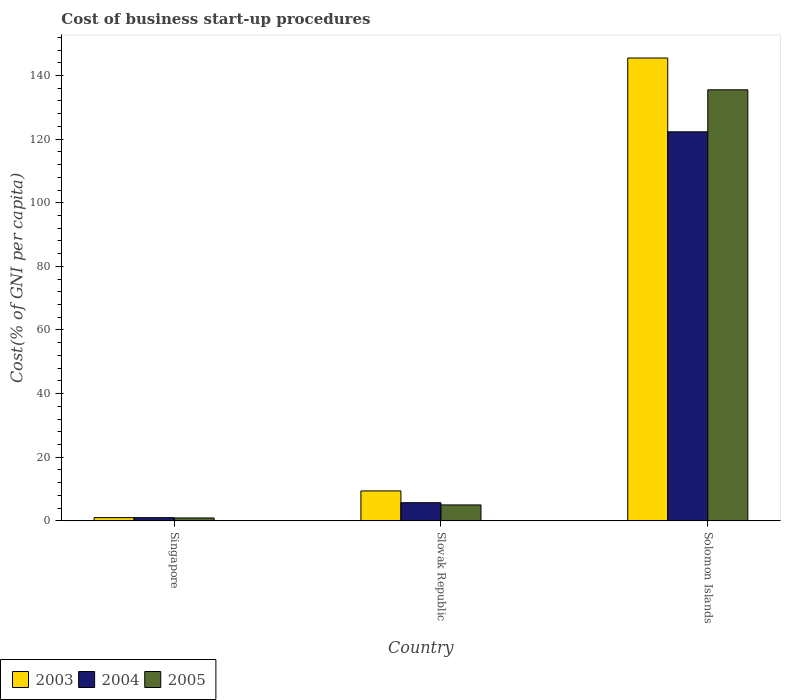How many different coloured bars are there?
Keep it short and to the point. 3. Are the number of bars per tick equal to the number of legend labels?
Make the answer very short. Yes. Are the number of bars on each tick of the X-axis equal?
Make the answer very short. Yes. How many bars are there on the 2nd tick from the right?
Offer a very short reply. 3. What is the label of the 2nd group of bars from the left?
Provide a short and direct response. Slovak Republic. What is the cost of business start-up procedures in 2003 in Slovak Republic?
Provide a succinct answer. 9.4. Across all countries, what is the maximum cost of business start-up procedures in 2003?
Make the answer very short. 145.5. In which country was the cost of business start-up procedures in 2003 maximum?
Ensure brevity in your answer.  Solomon Islands. In which country was the cost of business start-up procedures in 2004 minimum?
Ensure brevity in your answer.  Singapore. What is the total cost of business start-up procedures in 2005 in the graph?
Keep it short and to the point. 141.4. What is the difference between the cost of business start-up procedures in 2004 in Singapore and that in Solomon Islands?
Offer a terse response. -121.3. What is the difference between the cost of business start-up procedures in 2003 in Slovak Republic and the cost of business start-up procedures in 2005 in Singapore?
Your answer should be very brief. 8.5. What is the average cost of business start-up procedures in 2005 per country?
Make the answer very short. 47.13. What is the difference between the cost of business start-up procedures of/in 2005 and cost of business start-up procedures of/in 2004 in Singapore?
Give a very brief answer. -0.1. What is the ratio of the cost of business start-up procedures in 2004 in Singapore to that in Solomon Islands?
Your answer should be compact. 0.01. Is the cost of business start-up procedures in 2005 in Singapore less than that in Slovak Republic?
Your answer should be compact. Yes. What is the difference between the highest and the second highest cost of business start-up procedures in 2005?
Make the answer very short. -4.1. What is the difference between the highest and the lowest cost of business start-up procedures in 2005?
Offer a terse response. 134.6. In how many countries, is the cost of business start-up procedures in 2004 greater than the average cost of business start-up procedures in 2004 taken over all countries?
Keep it short and to the point. 1. What does the 1st bar from the left in Singapore represents?
Provide a succinct answer. 2003. What does the 3rd bar from the right in Slovak Republic represents?
Provide a short and direct response. 2003. Is it the case that in every country, the sum of the cost of business start-up procedures in 2005 and cost of business start-up procedures in 2003 is greater than the cost of business start-up procedures in 2004?
Provide a short and direct response. Yes. How many bars are there?
Your answer should be very brief. 9. How many countries are there in the graph?
Your response must be concise. 3. Are the values on the major ticks of Y-axis written in scientific E-notation?
Provide a short and direct response. No. Does the graph contain any zero values?
Offer a very short reply. No. Where does the legend appear in the graph?
Ensure brevity in your answer.  Bottom left. How many legend labels are there?
Give a very brief answer. 3. How are the legend labels stacked?
Make the answer very short. Horizontal. What is the title of the graph?
Offer a very short reply. Cost of business start-up procedures. Does "1988" appear as one of the legend labels in the graph?
Offer a terse response. No. What is the label or title of the Y-axis?
Ensure brevity in your answer.  Cost(% of GNI per capita). What is the Cost(% of GNI per capita) in 2003 in Singapore?
Ensure brevity in your answer.  1. What is the Cost(% of GNI per capita) in 2004 in Singapore?
Make the answer very short. 1. What is the Cost(% of GNI per capita) in 2005 in Singapore?
Make the answer very short. 0.9. What is the Cost(% of GNI per capita) of 2005 in Slovak Republic?
Offer a terse response. 5. What is the Cost(% of GNI per capita) in 2003 in Solomon Islands?
Ensure brevity in your answer.  145.5. What is the Cost(% of GNI per capita) in 2004 in Solomon Islands?
Provide a succinct answer. 122.3. What is the Cost(% of GNI per capita) of 2005 in Solomon Islands?
Offer a very short reply. 135.5. Across all countries, what is the maximum Cost(% of GNI per capita) of 2003?
Keep it short and to the point. 145.5. Across all countries, what is the maximum Cost(% of GNI per capita) of 2004?
Give a very brief answer. 122.3. Across all countries, what is the maximum Cost(% of GNI per capita) of 2005?
Provide a short and direct response. 135.5. Across all countries, what is the minimum Cost(% of GNI per capita) of 2003?
Offer a terse response. 1. What is the total Cost(% of GNI per capita) of 2003 in the graph?
Offer a terse response. 155.9. What is the total Cost(% of GNI per capita) of 2004 in the graph?
Offer a terse response. 129. What is the total Cost(% of GNI per capita) of 2005 in the graph?
Give a very brief answer. 141.4. What is the difference between the Cost(% of GNI per capita) in 2005 in Singapore and that in Slovak Republic?
Make the answer very short. -4.1. What is the difference between the Cost(% of GNI per capita) in 2003 in Singapore and that in Solomon Islands?
Provide a short and direct response. -144.5. What is the difference between the Cost(% of GNI per capita) of 2004 in Singapore and that in Solomon Islands?
Keep it short and to the point. -121.3. What is the difference between the Cost(% of GNI per capita) of 2005 in Singapore and that in Solomon Islands?
Give a very brief answer. -134.6. What is the difference between the Cost(% of GNI per capita) of 2003 in Slovak Republic and that in Solomon Islands?
Offer a very short reply. -136.1. What is the difference between the Cost(% of GNI per capita) of 2004 in Slovak Republic and that in Solomon Islands?
Offer a very short reply. -116.6. What is the difference between the Cost(% of GNI per capita) of 2005 in Slovak Republic and that in Solomon Islands?
Provide a succinct answer. -130.5. What is the difference between the Cost(% of GNI per capita) in 2003 in Singapore and the Cost(% of GNI per capita) in 2004 in Slovak Republic?
Ensure brevity in your answer.  -4.7. What is the difference between the Cost(% of GNI per capita) in 2003 in Singapore and the Cost(% of GNI per capita) in 2005 in Slovak Republic?
Offer a very short reply. -4. What is the difference between the Cost(% of GNI per capita) of 2003 in Singapore and the Cost(% of GNI per capita) of 2004 in Solomon Islands?
Keep it short and to the point. -121.3. What is the difference between the Cost(% of GNI per capita) in 2003 in Singapore and the Cost(% of GNI per capita) in 2005 in Solomon Islands?
Your answer should be very brief. -134.5. What is the difference between the Cost(% of GNI per capita) in 2004 in Singapore and the Cost(% of GNI per capita) in 2005 in Solomon Islands?
Offer a very short reply. -134.5. What is the difference between the Cost(% of GNI per capita) of 2003 in Slovak Republic and the Cost(% of GNI per capita) of 2004 in Solomon Islands?
Ensure brevity in your answer.  -112.9. What is the difference between the Cost(% of GNI per capita) in 2003 in Slovak Republic and the Cost(% of GNI per capita) in 2005 in Solomon Islands?
Your response must be concise. -126.1. What is the difference between the Cost(% of GNI per capita) in 2004 in Slovak Republic and the Cost(% of GNI per capita) in 2005 in Solomon Islands?
Your answer should be very brief. -129.8. What is the average Cost(% of GNI per capita) of 2003 per country?
Your answer should be compact. 51.97. What is the average Cost(% of GNI per capita) of 2005 per country?
Your answer should be compact. 47.13. What is the difference between the Cost(% of GNI per capita) in 2003 and Cost(% of GNI per capita) in 2004 in Singapore?
Provide a succinct answer. 0. What is the difference between the Cost(% of GNI per capita) in 2003 and Cost(% of GNI per capita) in 2005 in Slovak Republic?
Your response must be concise. 4.4. What is the difference between the Cost(% of GNI per capita) of 2003 and Cost(% of GNI per capita) of 2004 in Solomon Islands?
Make the answer very short. 23.2. What is the ratio of the Cost(% of GNI per capita) in 2003 in Singapore to that in Slovak Republic?
Give a very brief answer. 0.11. What is the ratio of the Cost(% of GNI per capita) in 2004 in Singapore to that in Slovak Republic?
Provide a succinct answer. 0.18. What is the ratio of the Cost(% of GNI per capita) in 2005 in Singapore to that in Slovak Republic?
Your answer should be very brief. 0.18. What is the ratio of the Cost(% of GNI per capita) of 2003 in Singapore to that in Solomon Islands?
Provide a succinct answer. 0.01. What is the ratio of the Cost(% of GNI per capita) in 2004 in Singapore to that in Solomon Islands?
Give a very brief answer. 0.01. What is the ratio of the Cost(% of GNI per capita) in 2005 in Singapore to that in Solomon Islands?
Provide a short and direct response. 0.01. What is the ratio of the Cost(% of GNI per capita) of 2003 in Slovak Republic to that in Solomon Islands?
Make the answer very short. 0.06. What is the ratio of the Cost(% of GNI per capita) in 2004 in Slovak Republic to that in Solomon Islands?
Ensure brevity in your answer.  0.05. What is the ratio of the Cost(% of GNI per capita) of 2005 in Slovak Republic to that in Solomon Islands?
Keep it short and to the point. 0.04. What is the difference between the highest and the second highest Cost(% of GNI per capita) of 2003?
Your answer should be very brief. 136.1. What is the difference between the highest and the second highest Cost(% of GNI per capita) of 2004?
Your response must be concise. 116.6. What is the difference between the highest and the second highest Cost(% of GNI per capita) of 2005?
Offer a terse response. 130.5. What is the difference between the highest and the lowest Cost(% of GNI per capita) in 2003?
Your answer should be very brief. 144.5. What is the difference between the highest and the lowest Cost(% of GNI per capita) in 2004?
Offer a terse response. 121.3. What is the difference between the highest and the lowest Cost(% of GNI per capita) of 2005?
Your answer should be compact. 134.6. 